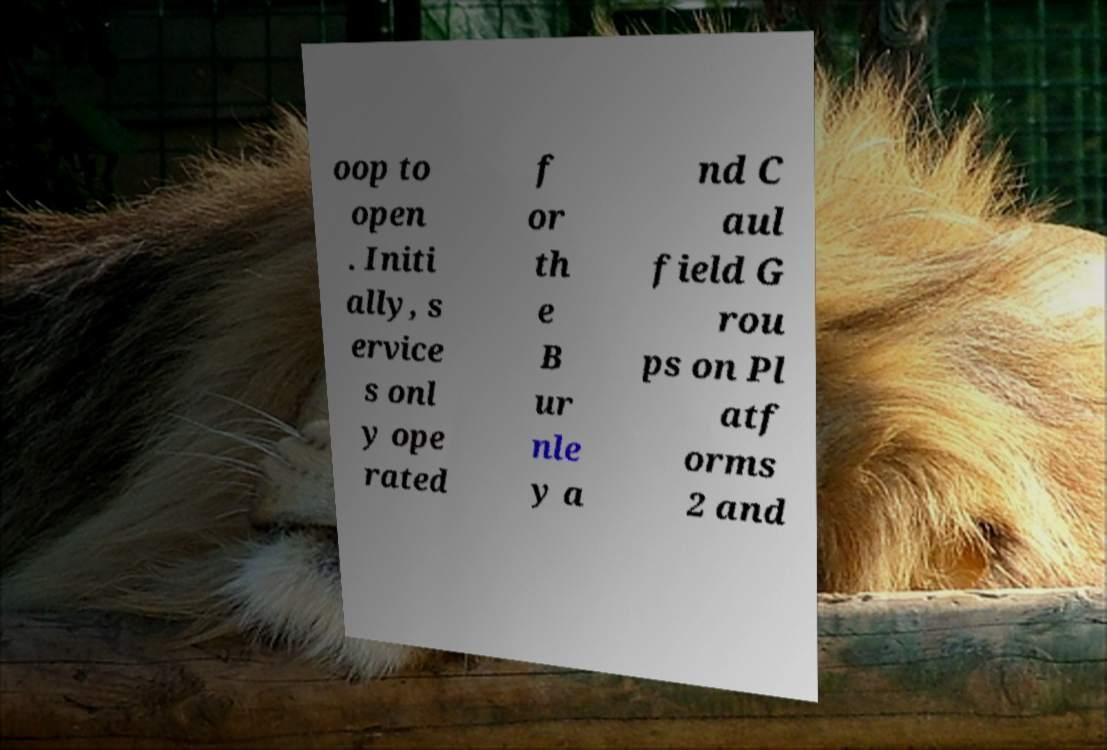Please read and relay the text visible in this image. What does it say? oop to open . Initi ally, s ervice s onl y ope rated f or th e B ur nle y a nd C aul field G rou ps on Pl atf orms 2 and 